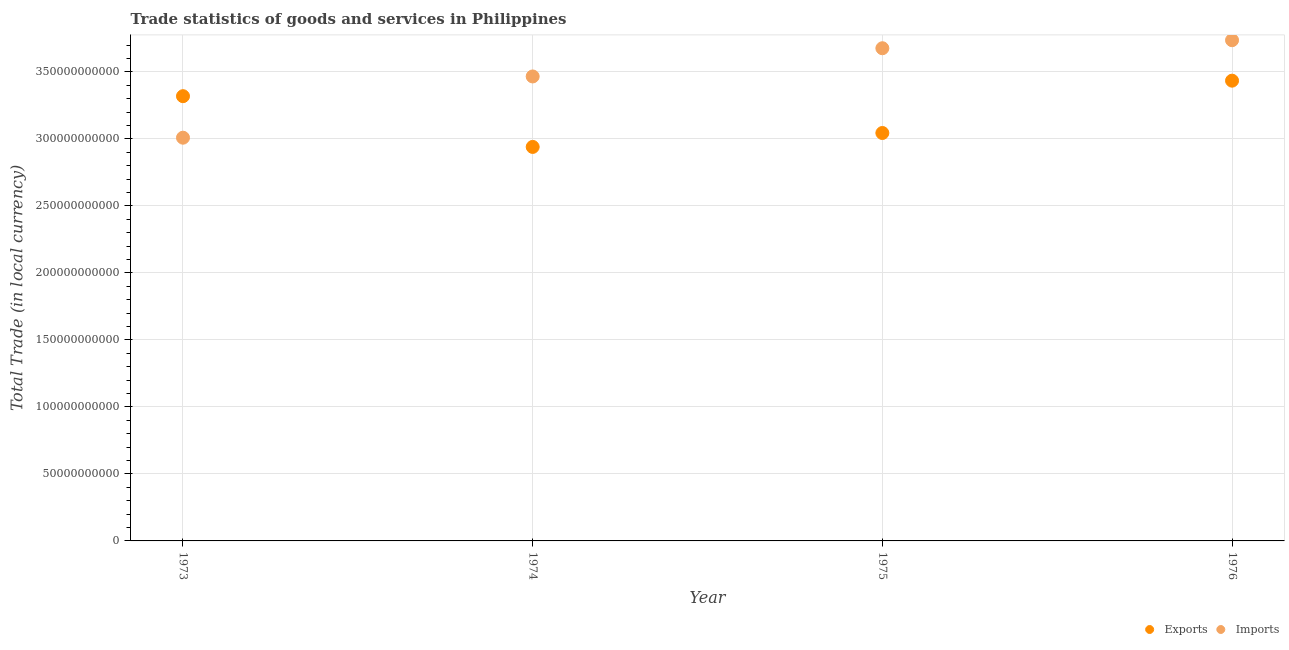How many different coloured dotlines are there?
Your response must be concise. 2. What is the export of goods and services in 1975?
Offer a very short reply. 3.04e+11. Across all years, what is the maximum imports of goods and services?
Offer a terse response. 3.74e+11. Across all years, what is the minimum imports of goods and services?
Provide a short and direct response. 3.01e+11. In which year was the imports of goods and services maximum?
Make the answer very short. 1976. In which year was the export of goods and services minimum?
Your answer should be compact. 1974. What is the total export of goods and services in the graph?
Ensure brevity in your answer.  1.27e+12. What is the difference between the export of goods and services in 1975 and that in 1976?
Your response must be concise. -3.90e+1. What is the difference between the export of goods and services in 1974 and the imports of goods and services in 1976?
Provide a short and direct response. -7.96e+1. What is the average imports of goods and services per year?
Offer a terse response. 3.47e+11. In the year 1975, what is the difference between the imports of goods and services and export of goods and services?
Provide a succinct answer. 6.32e+1. What is the ratio of the export of goods and services in 1975 to that in 1976?
Ensure brevity in your answer.  0.89. What is the difference between the highest and the second highest export of goods and services?
Give a very brief answer. 1.16e+1. What is the difference between the highest and the lowest export of goods and services?
Make the answer very short. 4.94e+1. Is the sum of the imports of goods and services in 1974 and 1976 greater than the maximum export of goods and services across all years?
Offer a terse response. Yes. Does the export of goods and services monotonically increase over the years?
Provide a short and direct response. No. Is the export of goods and services strictly greater than the imports of goods and services over the years?
Provide a short and direct response. No. How many dotlines are there?
Ensure brevity in your answer.  2. What is the difference between two consecutive major ticks on the Y-axis?
Provide a short and direct response. 5.00e+1. Are the values on the major ticks of Y-axis written in scientific E-notation?
Offer a very short reply. No. Where does the legend appear in the graph?
Your answer should be very brief. Bottom right. What is the title of the graph?
Offer a terse response. Trade statistics of goods and services in Philippines. Does "Measles" appear as one of the legend labels in the graph?
Keep it short and to the point. No. What is the label or title of the X-axis?
Ensure brevity in your answer.  Year. What is the label or title of the Y-axis?
Offer a terse response. Total Trade (in local currency). What is the Total Trade (in local currency) in Exports in 1973?
Give a very brief answer. 3.32e+11. What is the Total Trade (in local currency) of Imports in 1973?
Provide a short and direct response. 3.01e+11. What is the Total Trade (in local currency) in Exports in 1974?
Offer a terse response. 2.94e+11. What is the Total Trade (in local currency) in Imports in 1974?
Ensure brevity in your answer.  3.47e+11. What is the Total Trade (in local currency) of Exports in 1975?
Provide a succinct answer. 3.04e+11. What is the Total Trade (in local currency) in Imports in 1975?
Your response must be concise. 3.68e+11. What is the Total Trade (in local currency) of Exports in 1976?
Keep it short and to the point. 3.43e+11. What is the Total Trade (in local currency) in Imports in 1976?
Offer a terse response. 3.74e+11. Across all years, what is the maximum Total Trade (in local currency) of Exports?
Offer a very short reply. 3.43e+11. Across all years, what is the maximum Total Trade (in local currency) in Imports?
Provide a short and direct response. 3.74e+11. Across all years, what is the minimum Total Trade (in local currency) in Exports?
Ensure brevity in your answer.  2.94e+11. Across all years, what is the minimum Total Trade (in local currency) of Imports?
Offer a terse response. 3.01e+11. What is the total Total Trade (in local currency) in Exports in the graph?
Your answer should be compact. 1.27e+12. What is the total Total Trade (in local currency) in Imports in the graph?
Offer a very short reply. 1.39e+12. What is the difference between the Total Trade (in local currency) in Exports in 1973 and that in 1974?
Offer a terse response. 3.79e+1. What is the difference between the Total Trade (in local currency) in Imports in 1973 and that in 1974?
Provide a succinct answer. -4.57e+1. What is the difference between the Total Trade (in local currency) in Exports in 1973 and that in 1975?
Your response must be concise. 2.75e+1. What is the difference between the Total Trade (in local currency) of Imports in 1973 and that in 1975?
Give a very brief answer. -6.68e+1. What is the difference between the Total Trade (in local currency) of Exports in 1973 and that in 1976?
Your answer should be compact. -1.16e+1. What is the difference between the Total Trade (in local currency) of Imports in 1973 and that in 1976?
Your answer should be compact. -7.27e+1. What is the difference between the Total Trade (in local currency) in Exports in 1974 and that in 1975?
Give a very brief answer. -1.04e+1. What is the difference between the Total Trade (in local currency) in Imports in 1974 and that in 1975?
Offer a very short reply. -2.11e+1. What is the difference between the Total Trade (in local currency) in Exports in 1974 and that in 1976?
Offer a very short reply. -4.94e+1. What is the difference between the Total Trade (in local currency) of Imports in 1974 and that in 1976?
Provide a succinct answer. -2.70e+1. What is the difference between the Total Trade (in local currency) in Exports in 1975 and that in 1976?
Ensure brevity in your answer.  -3.90e+1. What is the difference between the Total Trade (in local currency) in Imports in 1975 and that in 1976?
Your answer should be compact. -5.99e+09. What is the difference between the Total Trade (in local currency) of Exports in 1973 and the Total Trade (in local currency) of Imports in 1974?
Make the answer very short. -1.47e+1. What is the difference between the Total Trade (in local currency) in Exports in 1973 and the Total Trade (in local currency) in Imports in 1975?
Offer a very short reply. -3.58e+1. What is the difference between the Total Trade (in local currency) of Exports in 1973 and the Total Trade (in local currency) of Imports in 1976?
Your answer should be compact. -4.18e+1. What is the difference between the Total Trade (in local currency) in Exports in 1974 and the Total Trade (in local currency) in Imports in 1975?
Provide a short and direct response. -7.36e+1. What is the difference between the Total Trade (in local currency) of Exports in 1974 and the Total Trade (in local currency) of Imports in 1976?
Your response must be concise. -7.96e+1. What is the difference between the Total Trade (in local currency) of Exports in 1975 and the Total Trade (in local currency) of Imports in 1976?
Provide a succinct answer. -6.92e+1. What is the average Total Trade (in local currency) of Exports per year?
Give a very brief answer. 3.18e+11. What is the average Total Trade (in local currency) in Imports per year?
Offer a terse response. 3.47e+11. In the year 1973, what is the difference between the Total Trade (in local currency) in Exports and Total Trade (in local currency) in Imports?
Offer a terse response. 3.10e+1. In the year 1974, what is the difference between the Total Trade (in local currency) in Exports and Total Trade (in local currency) in Imports?
Provide a short and direct response. -5.26e+1. In the year 1975, what is the difference between the Total Trade (in local currency) in Exports and Total Trade (in local currency) in Imports?
Your answer should be very brief. -6.32e+1. In the year 1976, what is the difference between the Total Trade (in local currency) of Exports and Total Trade (in local currency) of Imports?
Provide a succinct answer. -3.02e+1. What is the ratio of the Total Trade (in local currency) of Exports in 1973 to that in 1974?
Provide a short and direct response. 1.13. What is the ratio of the Total Trade (in local currency) in Imports in 1973 to that in 1974?
Keep it short and to the point. 0.87. What is the ratio of the Total Trade (in local currency) of Exports in 1973 to that in 1975?
Offer a very short reply. 1.09. What is the ratio of the Total Trade (in local currency) in Imports in 1973 to that in 1975?
Your response must be concise. 0.82. What is the ratio of the Total Trade (in local currency) of Exports in 1973 to that in 1976?
Keep it short and to the point. 0.97. What is the ratio of the Total Trade (in local currency) of Imports in 1973 to that in 1976?
Your response must be concise. 0.81. What is the ratio of the Total Trade (in local currency) in Exports in 1974 to that in 1975?
Keep it short and to the point. 0.97. What is the ratio of the Total Trade (in local currency) in Imports in 1974 to that in 1975?
Your response must be concise. 0.94. What is the ratio of the Total Trade (in local currency) of Exports in 1974 to that in 1976?
Your response must be concise. 0.86. What is the ratio of the Total Trade (in local currency) in Imports in 1974 to that in 1976?
Provide a short and direct response. 0.93. What is the ratio of the Total Trade (in local currency) in Exports in 1975 to that in 1976?
Your answer should be compact. 0.89. What is the difference between the highest and the second highest Total Trade (in local currency) of Exports?
Provide a short and direct response. 1.16e+1. What is the difference between the highest and the second highest Total Trade (in local currency) in Imports?
Offer a very short reply. 5.99e+09. What is the difference between the highest and the lowest Total Trade (in local currency) of Exports?
Provide a short and direct response. 4.94e+1. What is the difference between the highest and the lowest Total Trade (in local currency) in Imports?
Your answer should be very brief. 7.27e+1. 